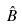<formula> <loc_0><loc_0><loc_500><loc_500>\hat { B }</formula> 